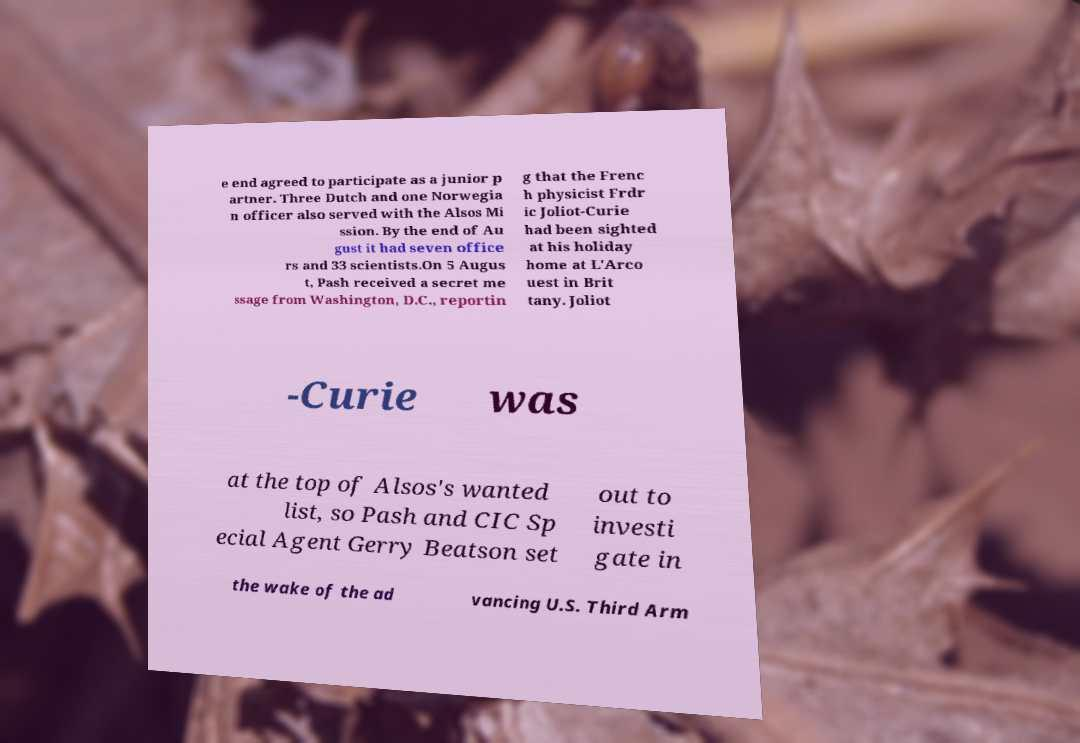For documentation purposes, I need the text within this image transcribed. Could you provide that? e end agreed to participate as a junior p artner. Three Dutch and one Norwegia n officer also served with the Alsos Mi ssion. By the end of Au gust it had seven office rs and 33 scientists.On 5 Augus t, Pash received a secret me ssage from Washington, D.C., reportin g that the Frenc h physicist Frdr ic Joliot-Curie had been sighted at his holiday home at L'Arco uest in Brit tany. Joliot -Curie was at the top of Alsos's wanted list, so Pash and CIC Sp ecial Agent Gerry Beatson set out to investi gate in the wake of the ad vancing U.S. Third Arm 